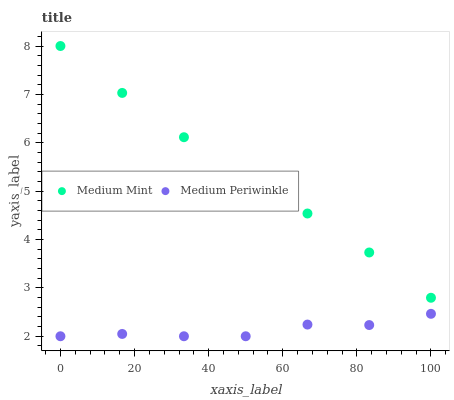Does Medium Periwinkle have the minimum area under the curve?
Answer yes or no. Yes. Does Medium Mint have the maximum area under the curve?
Answer yes or no. Yes. Does Medium Periwinkle have the maximum area under the curve?
Answer yes or no. No. Is Medium Mint the smoothest?
Answer yes or no. Yes. Is Medium Periwinkle the roughest?
Answer yes or no. Yes. Is Medium Periwinkle the smoothest?
Answer yes or no. No. Does Medium Periwinkle have the lowest value?
Answer yes or no. Yes. Does Medium Mint have the highest value?
Answer yes or no. Yes. Does Medium Periwinkle have the highest value?
Answer yes or no. No. Is Medium Periwinkle less than Medium Mint?
Answer yes or no. Yes. Is Medium Mint greater than Medium Periwinkle?
Answer yes or no. Yes. Does Medium Periwinkle intersect Medium Mint?
Answer yes or no. No. 